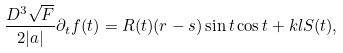<formula> <loc_0><loc_0><loc_500><loc_500>\frac { D ^ { 3 } \sqrt { F } } { 2 | a | } \partial _ { t } f ( t ) = R ( t ) ( r - s ) \sin t \cos t + k l S ( t ) ,</formula> 